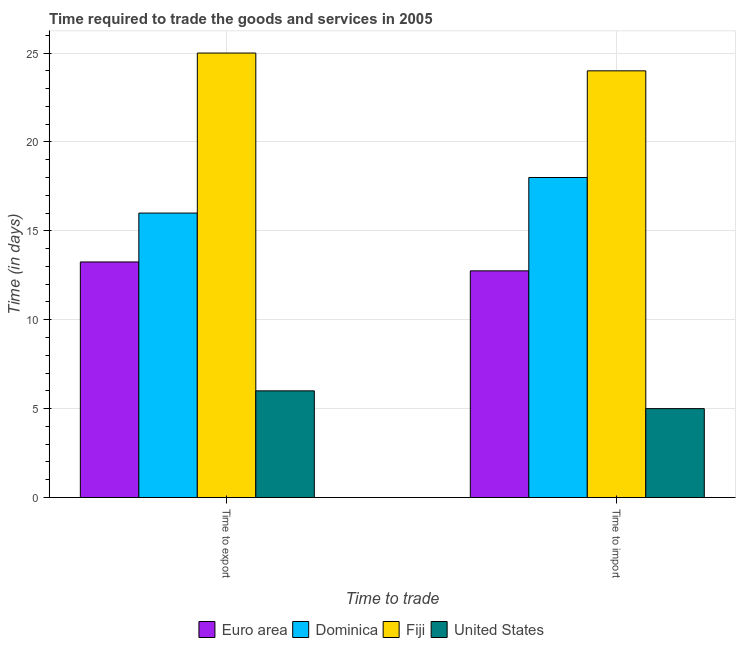How many groups of bars are there?
Give a very brief answer. 2. Are the number of bars per tick equal to the number of legend labels?
Ensure brevity in your answer.  Yes. Are the number of bars on each tick of the X-axis equal?
Your response must be concise. Yes. What is the label of the 1st group of bars from the left?
Provide a short and direct response. Time to export. What is the time to import in Euro area?
Keep it short and to the point. 12.75. Across all countries, what is the maximum time to import?
Keep it short and to the point. 24. Across all countries, what is the minimum time to export?
Provide a succinct answer. 6. In which country was the time to export maximum?
Ensure brevity in your answer.  Fiji. In which country was the time to export minimum?
Offer a very short reply. United States. What is the total time to export in the graph?
Your answer should be very brief. 60.25. What is the difference between the time to export in United States and that in Dominica?
Provide a succinct answer. -10. What is the difference between the time to import in Euro area and the time to export in Dominica?
Your answer should be very brief. -3.25. What is the average time to import per country?
Your answer should be compact. 14.94. What is the ratio of the time to import in United States to that in Euro area?
Offer a terse response. 0.39. What does the 1st bar from the left in Time to export represents?
Provide a succinct answer. Euro area. What does the 3rd bar from the right in Time to import represents?
Make the answer very short. Dominica. Are all the bars in the graph horizontal?
Keep it short and to the point. No. How many countries are there in the graph?
Offer a terse response. 4. Are the values on the major ticks of Y-axis written in scientific E-notation?
Offer a very short reply. No. Does the graph contain any zero values?
Your response must be concise. No. Does the graph contain grids?
Ensure brevity in your answer.  Yes. How are the legend labels stacked?
Give a very brief answer. Horizontal. What is the title of the graph?
Offer a very short reply. Time required to trade the goods and services in 2005. Does "Belarus" appear as one of the legend labels in the graph?
Your response must be concise. No. What is the label or title of the X-axis?
Your answer should be compact. Time to trade. What is the label or title of the Y-axis?
Ensure brevity in your answer.  Time (in days). What is the Time (in days) in Euro area in Time to export?
Offer a very short reply. 13.25. What is the Time (in days) of United States in Time to export?
Provide a succinct answer. 6. What is the Time (in days) of Euro area in Time to import?
Offer a terse response. 12.75. What is the Time (in days) of Fiji in Time to import?
Offer a very short reply. 24. What is the Time (in days) in United States in Time to import?
Offer a very short reply. 5. Across all Time to trade, what is the maximum Time (in days) of Euro area?
Your answer should be very brief. 13.25. Across all Time to trade, what is the maximum Time (in days) of Dominica?
Make the answer very short. 18. Across all Time to trade, what is the maximum Time (in days) of United States?
Give a very brief answer. 6. Across all Time to trade, what is the minimum Time (in days) in Euro area?
Provide a short and direct response. 12.75. Across all Time to trade, what is the minimum Time (in days) of Dominica?
Your response must be concise. 16. What is the total Time (in days) of Fiji in the graph?
Your answer should be very brief. 49. What is the total Time (in days) in United States in the graph?
Ensure brevity in your answer.  11. What is the difference between the Time (in days) of Dominica in Time to export and that in Time to import?
Your answer should be compact. -2. What is the difference between the Time (in days) in United States in Time to export and that in Time to import?
Make the answer very short. 1. What is the difference between the Time (in days) in Euro area in Time to export and the Time (in days) in Dominica in Time to import?
Give a very brief answer. -4.75. What is the difference between the Time (in days) in Euro area in Time to export and the Time (in days) in Fiji in Time to import?
Make the answer very short. -10.75. What is the difference between the Time (in days) in Euro area in Time to export and the Time (in days) in United States in Time to import?
Offer a very short reply. 8.25. What is the difference between the Time (in days) of Dominica in Time to export and the Time (in days) of Fiji in Time to import?
Ensure brevity in your answer.  -8. What is the difference between the Time (in days) in Fiji in Time to export and the Time (in days) in United States in Time to import?
Your answer should be very brief. 20. What is the average Time (in days) in Fiji per Time to trade?
Ensure brevity in your answer.  24.5. What is the average Time (in days) of United States per Time to trade?
Offer a very short reply. 5.5. What is the difference between the Time (in days) in Euro area and Time (in days) in Dominica in Time to export?
Your answer should be very brief. -2.75. What is the difference between the Time (in days) in Euro area and Time (in days) in Fiji in Time to export?
Your answer should be very brief. -11.75. What is the difference between the Time (in days) of Euro area and Time (in days) of United States in Time to export?
Your response must be concise. 7.25. What is the difference between the Time (in days) in Dominica and Time (in days) in United States in Time to export?
Ensure brevity in your answer.  10. What is the difference between the Time (in days) of Fiji and Time (in days) of United States in Time to export?
Offer a very short reply. 19. What is the difference between the Time (in days) of Euro area and Time (in days) of Dominica in Time to import?
Offer a very short reply. -5.25. What is the difference between the Time (in days) of Euro area and Time (in days) of Fiji in Time to import?
Your answer should be compact. -11.25. What is the difference between the Time (in days) in Euro area and Time (in days) in United States in Time to import?
Ensure brevity in your answer.  7.75. What is the difference between the Time (in days) of Dominica and Time (in days) of United States in Time to import?
Ensure brevity in your answer.  13. What is the difference between the Time (in days) of Fiji and Time (in days) of United States in Time to import?
Make the answer very short. 19. What is the ratio of the Time (in days) of Euro area in Time to export to that in Time to import?
Offer a terse response. 1.04. What is the ratio of the Time (in days) of Fiji in Time to export to that in Time to import?
Keep it short and to the point. 1.04. What is the ratio of the Time (in days) in United States in Time to export to that in Time to import?
Your answer should be compact. 1.2. What is the difference between the highest and the second highest Time (in days) of Euro area?
Provide a short and direct response. 0.5. What is the difference between the highest and the second highest Time (in days) of United States?
Provide a succinct answer. 1. What is the difference between the highest and the lowest Time (in days) in Euro area?
Your answer should be compact. 0.5. What is the difference between the highest and the lowest Time (in days) in Dominica?
Your response must be concise. 2. 